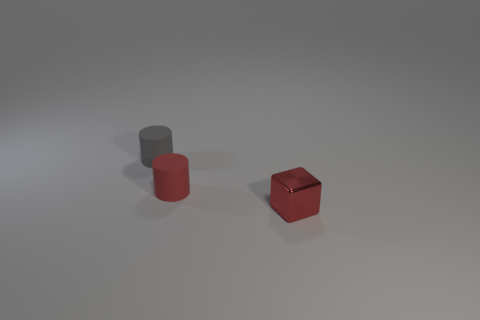How many other things are the same size as the gray cylinder?
Your response must be concise. 2. Is the number of tiny metal things less than the number of objects?
Give a very brief answer. Yes. What is the shape of the red metal object?
Give a very brief answer. Cube. There is a object that is to the left of the tiny red matte thing; does it have the same color as the small cube?
Provide a short and direct response. No. There is a object that is in front of the small gray cylinder and behind the block; what shape is it?
Make the answer very short. Cylinder. What is the color of the cylinder that is on the left side of the red matte thing?
Give a very brief answer. Gray. Are there any other things that are the same color as the small cube?
Provide a short and direct response. Yes. Is the metallic block the same size as the gray cylinder?
Keep it short and to the point. Yes. There is a thing that is on the left side of the block and in front of the gray rubber thing; how big is it?
Your response must be concise. Small. How many tiny gray objects are made of the same material as the small gray cylinder?
Offer a very short reply. 0. 